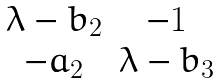Convert formula to latex. <formula><loc_0><loc_0><loc_500><loc_500>\begin{matrix} \lambda - b _ { 2 } & - 1 \\ - a _ { 2 } & \lambda - b _ { 3 } \end{matrix}</formula> 